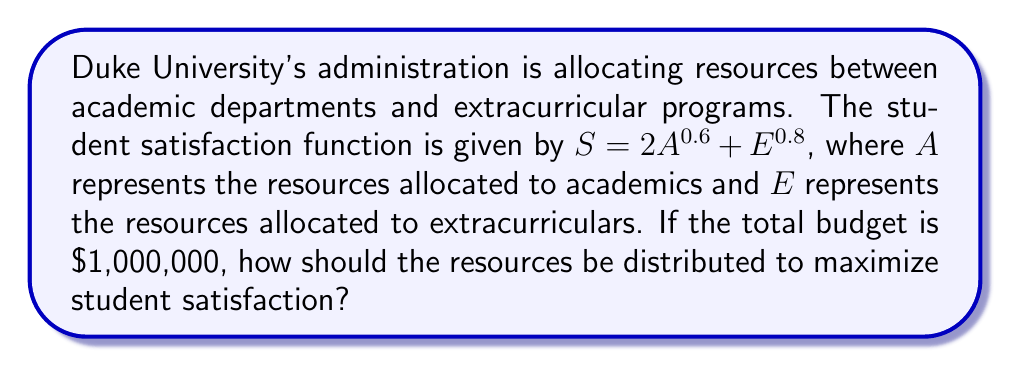Provide a solution to this math problem. 1) We need to maximize $S = 2A^{0.6} + E^{0.8}$ subject to the constraint $A + E = 1,000,000$.

2) Let's use the method of Lagrange multipliers. Define:
   $L(A, E, \lambda) = 2A^{0.6} + E^{0.8} - \lambda(A + E - 1,000,000)$

3) Take partial derivatives and set them to zero:
   $\frac{\partial L}{\partial A} = 1.2A^{-0.4} - \lambda = 0$
   $\frac{\partial L}{\partial E} = 0.8E^{-0.2} - \lambda = 0$
   $\frac{\partial L}{\partial \lambda} = A + E - 1,000,000 = 0$

4) From the first two equations:
   $1.2A^{-0.4} = 0.8E^{-0.2}$

5) Rearranging:
   $\frac{E^{0.2}}{A^{0.4}} = \frac{2}{3}$

6) Let $E = kA$. Then:
   $\frac{(kA)^{0.2}}{A^{0.4}} = \frac{2}{3}$
   $k^{0.2} = \frac{2}{3}$
   $k = (\frac{2}{3})^5 = \frac{32}{243}$

7) Substituting into the constraint equation:
   $A + \frac{32}{243}A = 1,000,000$
   $A(1 + \frac{32}{243}) = 1,000,000$
   $A = \frac{1,000,000 * 243}{275} = 883,636.36$

8) Therefore:
   $E = 1,000,000 - 883,636.36 = 116,363.64$

9) Rounding to the nearest dollar:
   $A = \$883,636$ and $E = \$116,364$
Answer: $A = \$883,636$, $E = \$116,364$ 